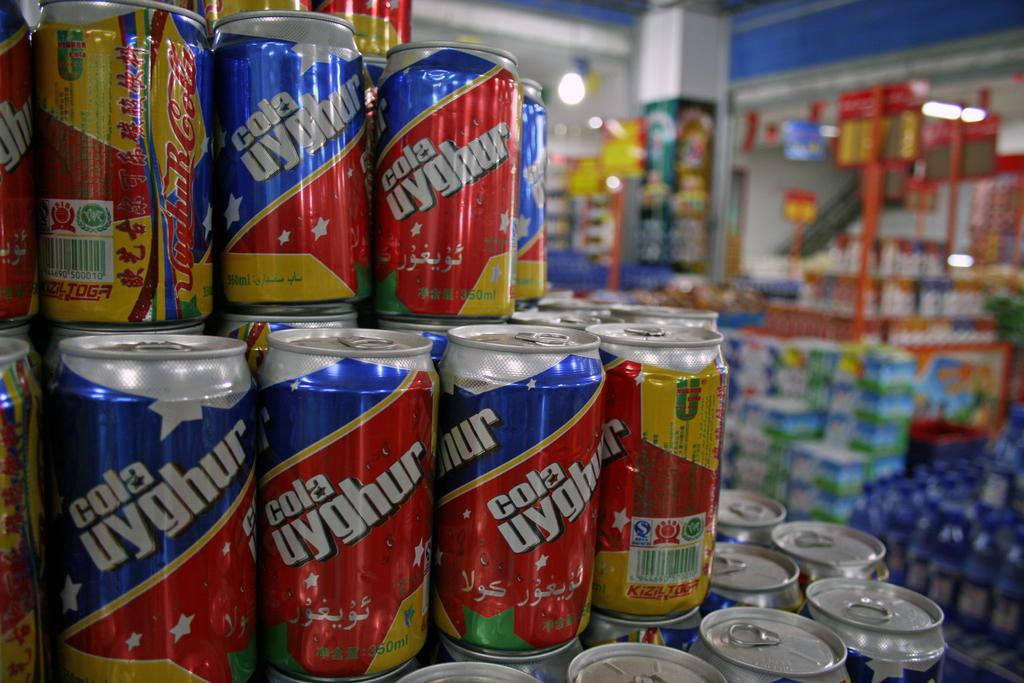<image>
Write a terse but informative summary of the picture. many cans of Cola Uyghur are for sale in a shop 